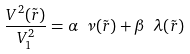Convert formula to latex. <formula><loc_0><loc_0><loc_500><loc_500>\frac { V ^ { 2 } ( \tilde { r } ) } { V ^ { 2 } _ { 1 } } = \alpha \ \nu ( \tilde { r } ) + \beta \ \lambda ( \tilde { r } )</formula> 